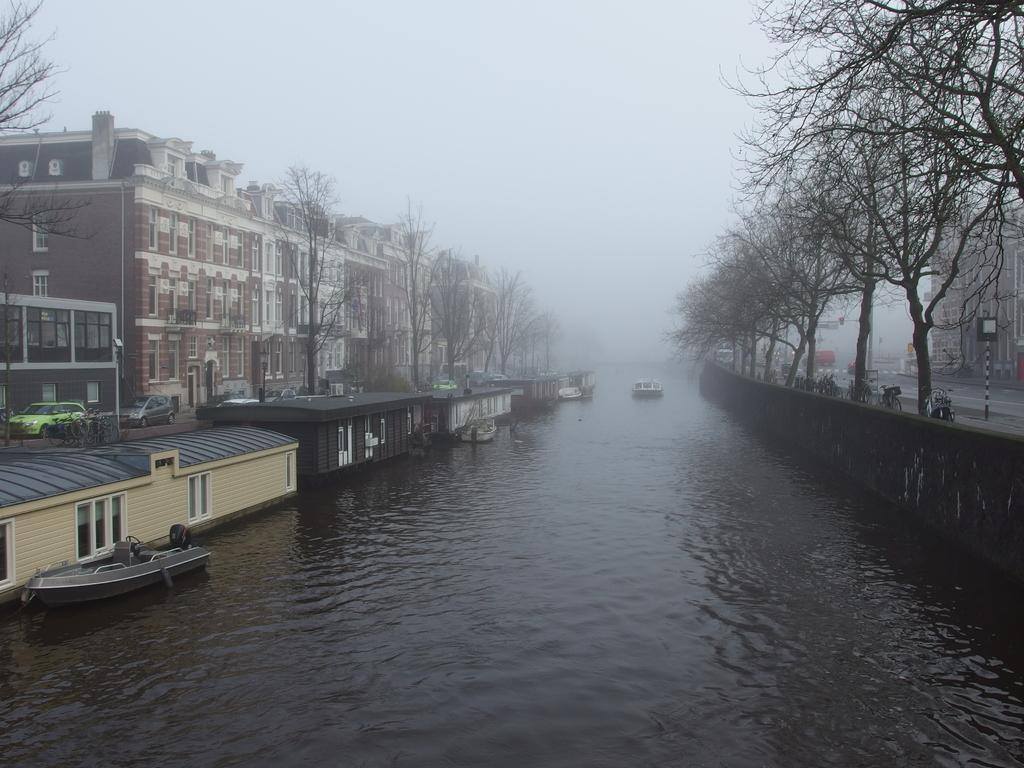What is the main feature of the image? The main feature of the image is water. What can be seen floating on the water? There are boats in the image. What is visible on both sides of the water? There are buildings on both sides of the image. What type of vegetation is present in the image? There are trees in the image. What is visible at the top of the image? The sky is visible at the top of the image. What atmospheric condition can be observed in the image? There is fog in the image. What decision does the army make in the image? There is no army present in the image, so no decision can be made. What type of pet can be seen playing near the trees in the image? There are no pets visible in the image; only boats, buildings, trees, and fog are present. 